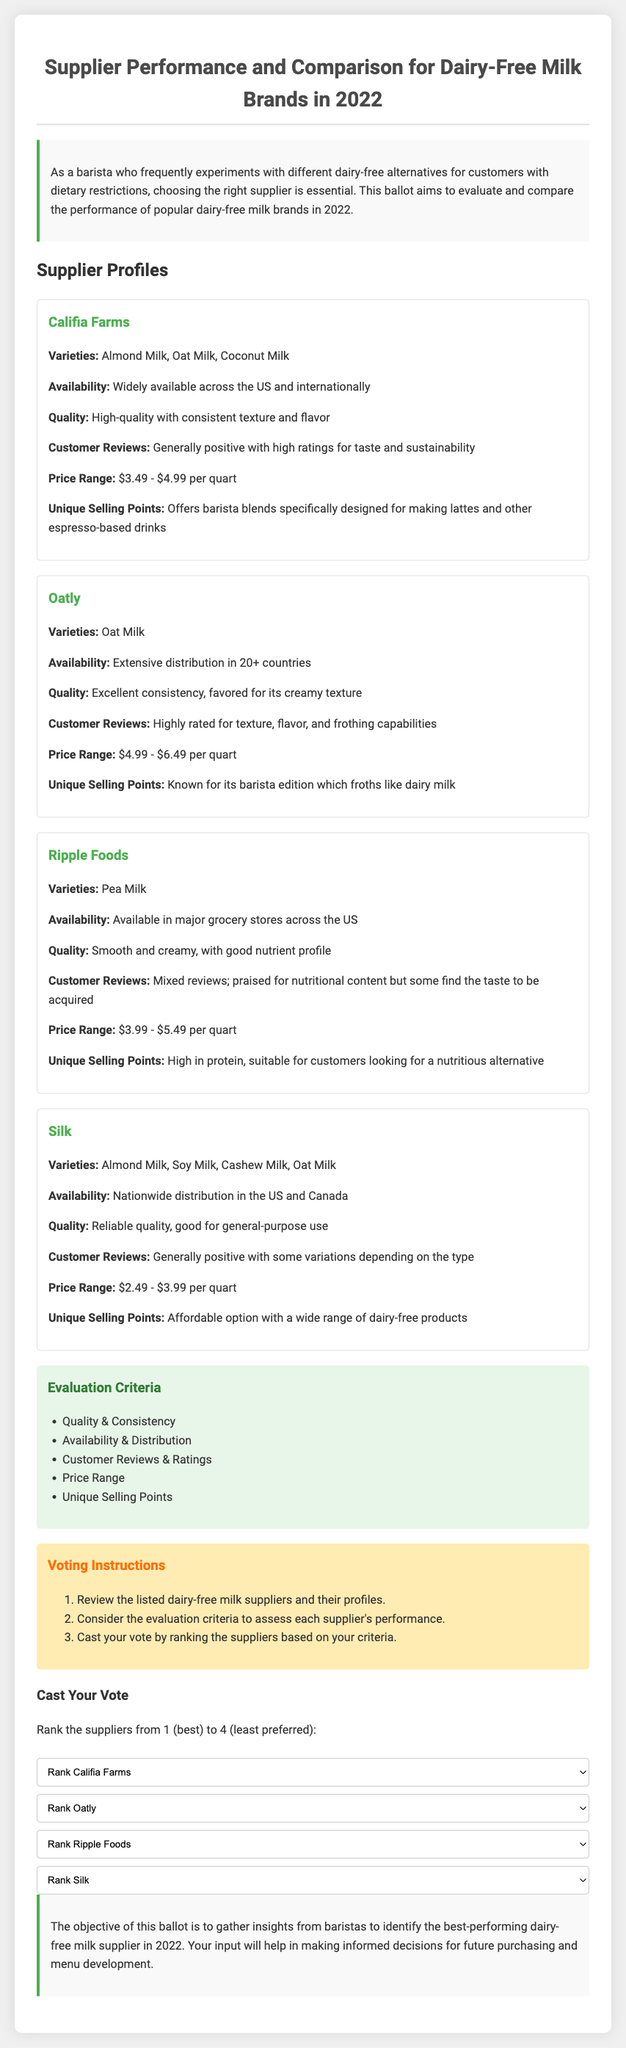What are the varieties offered by Califia Farms? Califia Farms provides Almond Milk, Oat Milk, and Coconut Milk as their varieties.
Answer: Almond Milk, Oat Milk, Coconut Milk What is the price range of Oatly? The document lists the price range of Oatly as between $4.99 and $6.49 per quart.
Answer: $4.99 - $6.49 Which supplier offers a barista blend? The supplier known for offering barista blends specifically for making lattes is Califia Farms.
Answer: Califia Farms What is the general customer sentiment towards Ripple Foods? Customer reviews for Ripple Foods are described as mixed; they are praised for nutritional content but some find the taste to be acquired.
Answer: Mixed reviews How many varieties does Silk have? Silk offers four varieties including Almond Milk, Soy Milk, Cashew Milk, and Oat Milk.
Answer: Four Which supplier has the highest starting price? Oatly has the highest starting price at $4.99 per quart.
Answer: Oatly What is the primary unique selling point of Ripple Foods? Ripple Foods’ unique selling point is that it is high in protein, making it a nutritious alternative.
Answer: High in protein What is the primary evaluation criterion used for ranking suppliers? The primary evaluation criteria include Quality & Consistency among others.
Answer: Quality & Consistency 